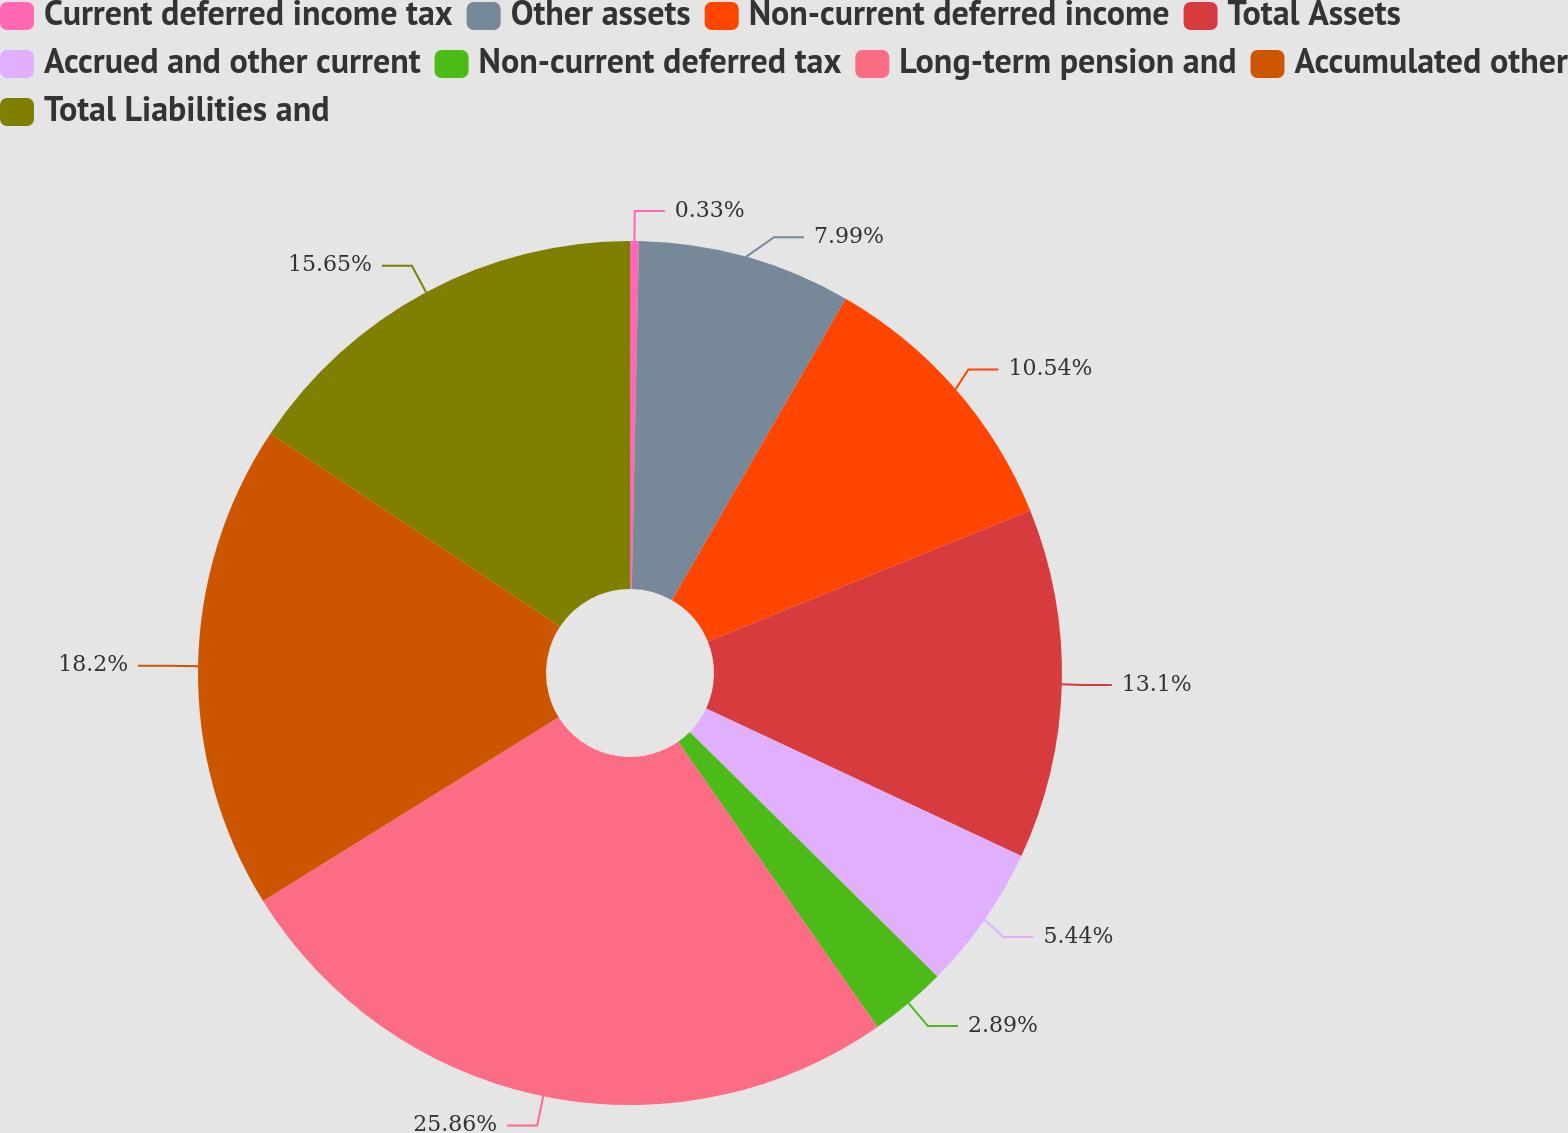Convert chart. <chart><loc_0><loc_0><loc_500><loc_500><pie_chart><fcel>Current deferred income tax<fcel>Other assets<fcel>Non-current deferred income<fcel>Total Assets<fcel>Accrued and other current<fcel>Non-current deferred tax<fcel>Long-term pension and<fcel>Accumulated other<fcel>Total Liabilities and<nl><fcel>0.33%<fcel>7.99%<fcel>10.54%<fcel>13.1%<fcel>5.44%<fcel>2.89%<fcel>25.86%<fcel>18.2%<fcel>15.65%<nl></chart> 